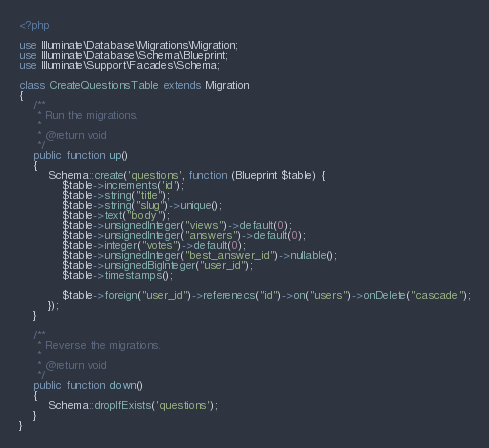<code> <loc_0><loc_0><loc_500><loc_500><_PHP_><?php

use Illuminate\Database\Migrations\Migration;
use Illuminate\Database\Schema\Blueprint;
use Illuminate\Support\Facades\Schema;

class CreateQuestionsTable extends Migration
{
    /**
     * Run the migrations.
     *
     * @return void
     */
    public function up()
    {
        Schema::create('questions', function (Blueprint $table) {
            $table->increments('id');
            $table->string("title");
            $table->string("slug")->unique();
            $table->text("body");
            $table->unsignedInteger("views")->default(0);
            $table->unsignedInteger("answers")->default(0);
            $table->integer("votes")->default(0);
            $table->unsignedInteger("best_answer_id")->nullable();
            $table->unsignedBigInteger("user_id");
            $table->timestamps();

            $table->foreign("user_id")->referenecs("id")->on("users")->onDelete("cascade");
        });
    }

    /**
     * Reverse the migrations.
     *
     * @return void
     */
    public function down()
    {
        Schema::dropIfExists('questions');
    }
}
</code> 